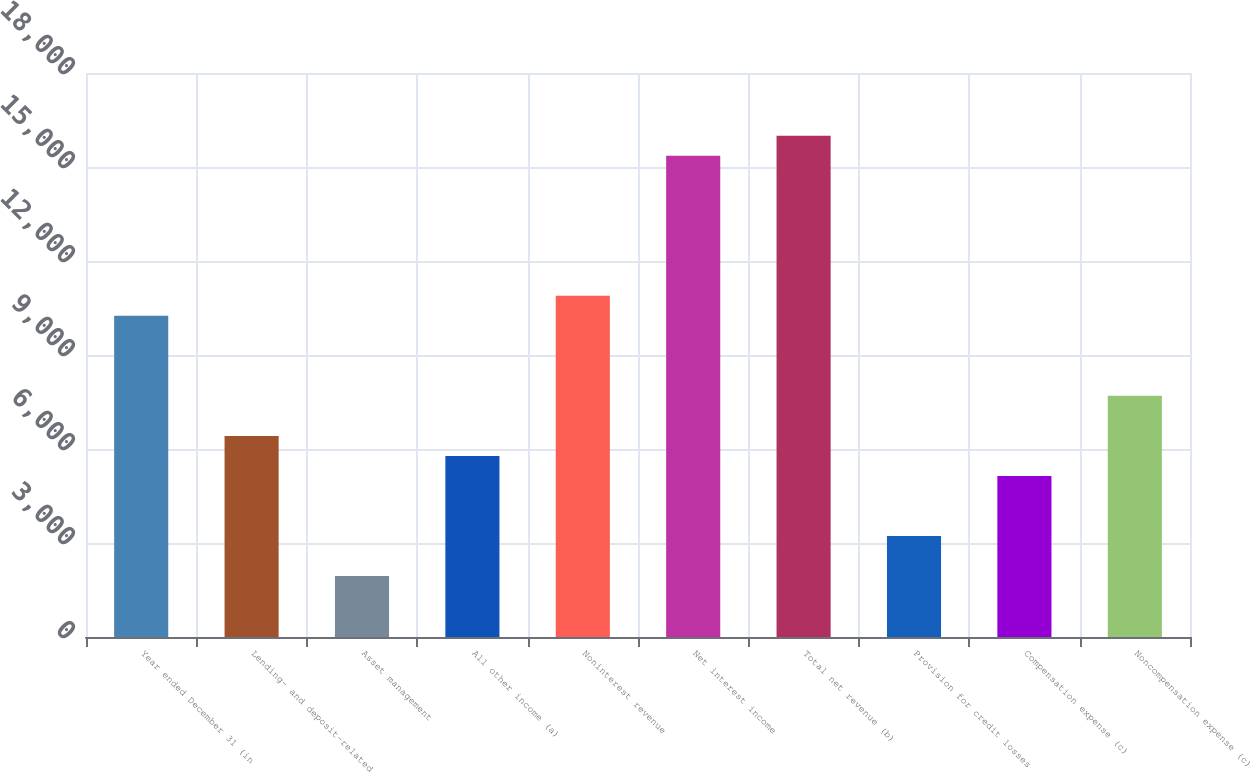Convert chart. <chart><loc_0><loc_0><loc_500><loc_500><bar_chart><fcel>Year ended December 31 (in<fcel>Lending- and deposit-related<fcel>Asset management<fcel>All other income (a)<fcel>Noninterest revenue<fcel>Net interest income<fcel>Total net revenue (b)<fcel>Provision for credit losses<fcel>Compensation expense (c)<fcel>Noncompensation expense (c)<nl><fcel>10250.8<fcel>6418<fcel>1946.4<fcel>5779.2<fcel>10889.6<fcel>15361.2<fcel>16000<fcel>3224<fcel>5140.4<fcel>7695.6<nl></chart> 